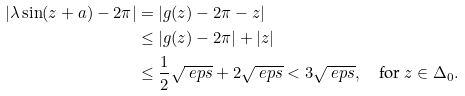Convert formula to latex. <formula><loc_0><loc_0><loc_500><loc_500>| \lambda \sin ( z + a ) - 2 \pi | & = | g ( z ) - 2 \pi - z | \\ & \leq | g ( z ) - 2 \pi | + | z | \\ & \leq \frac { 1 } { 2 } \sqrt { \ e p s } + 2 \sqrt { \ e p s } < 3 \sqrt { \ e p s } , \quad \text {for } z \in \Delta _ { 0 } .</formula> 